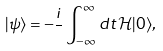Convert formula to latex. <formula><loc_0><loc_0><loc_500><loc_500>| \psi \rangle = - \frac { i } { } \int _ { - \infty } ^ { \infty } d t \, \mathcal { H } | 0 \rangle ,</formula> 